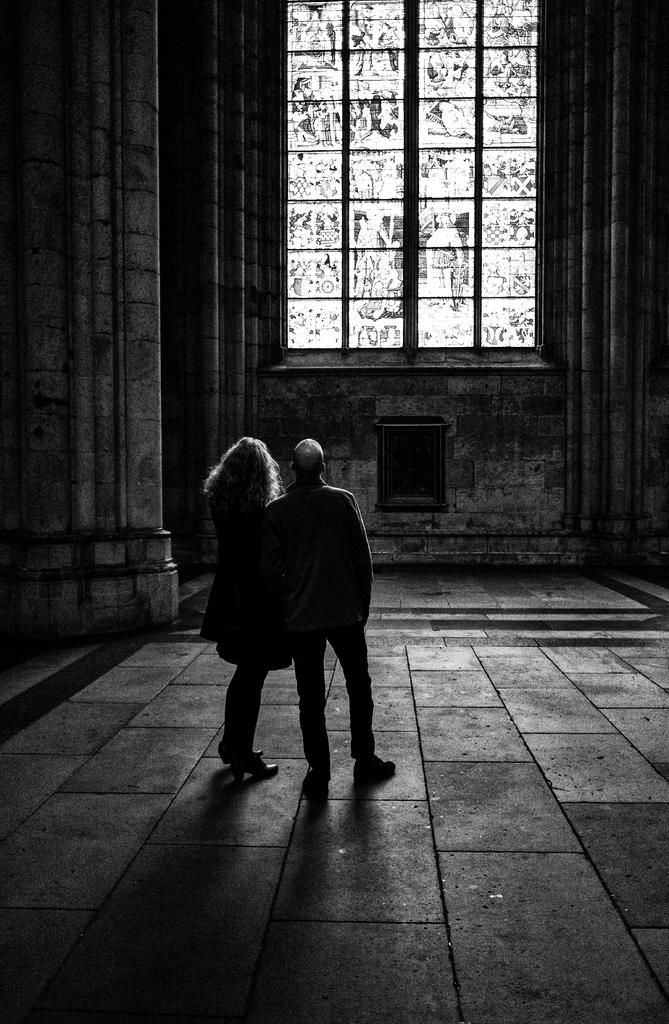What is the color scheme of the image? The image is black and white. How many people are present in the image? There are two persons standing in the image. What instrument did the person on the left use to make the decision in the image? There is no instrument or decision-making process depicted in the image, as it only shows two people standing. 